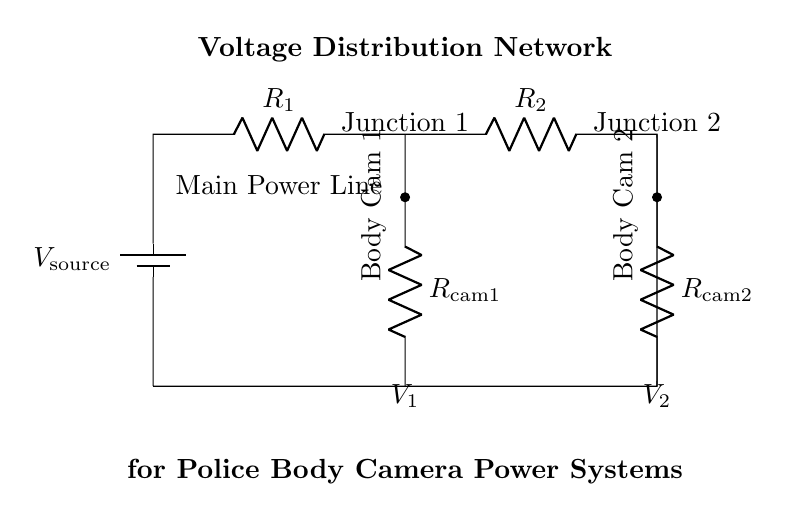What is the voltage source in this circuit? The voltage source is labeled as V_source in the diagram, representing the input voltage that supplies power to the entire circuit.
Answer: V_source What are the resistor values for body camera 1? The resistor for body camera 1 is labeled R_cam1; however, the specific resistance value is not indicated in the diagram.
Answer: R_cam1 Which component has the lowest voltage drop? In a current divider, the component with the higher resistance drops more voltage. Without resistance values, we can't determine which component has the lowest voltage drop.
Answer: Cannot determine What is the role of R_1 and R_2 in this circuit? R_1 and R_2 are resistors that divide the total current supplied by the voltage source into two separate paths for the body cameras based on their resistances.
Answer: Current division If R_1 is increased, what happens to V_1? If R_1 is increased, according to the principles of current division, V_1 will increase because more voltage drops across the higher resistance R_1, assuming constant supply voltage.
Answer: V_1 increases What is the total current in the circuit? The total current is not directly specified in the diagram, as it would depend on the values of the resistors and the voltage source.
Answer: Cannot determine How many body cameras can be powered by this distribution network? The diagram shows two body cameras connected in parallel, indicating that the current divider can power at least two cameras simultaneously.
Answer: Two cameras 